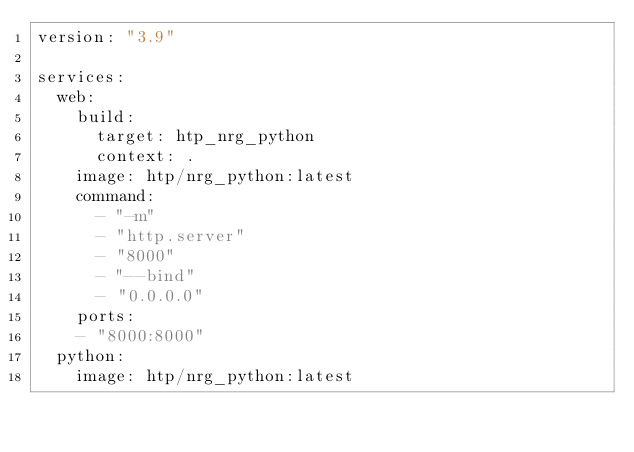Convert code to text. <code><loc_0><loc_0><loc_500><loc_500><_YAML_>version: "3.9"

services:
  web:
    build:
      target: htp_nrg_python
      context: .
    image: htp/nrg_python:latest
    command:
      - "-m"
      - "http.server"
      - "8000"
      - "--bind"
      - "0.0.0.0"
    ports:
    - "8000:8000"
  python:
    image: htp/nrg_python:latest
</code> 